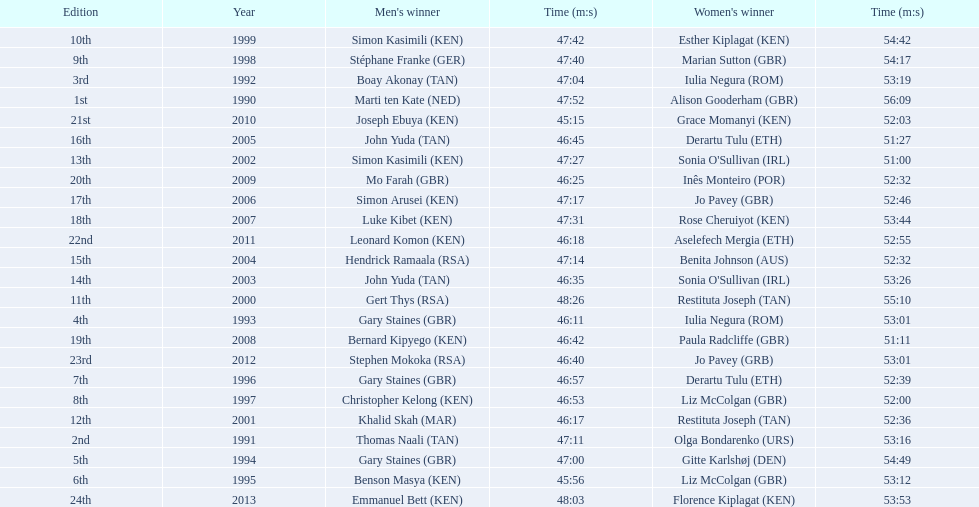What years were the races held? 1990, 1991, 1992, 1993, 1994, 1995, 1996, 1997, 1998, 1999, 2000, 2001, 2002, 2003, 2004, 2005, 2006, 2007, 2008, 2009, 2010, 2011, 2012, 2013. Who was the woman's winner of the 2003 race? Sonia O'Sullivan (IRL). What was her time? 53:26. 